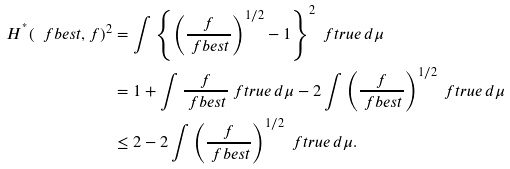<formula> <loc_0><loc_0><loc_500><loc_500>H ^ { ^ { * } } ( \ f b e s t , f ) ^ { 2 } & = \int \left \{ \left ( \frac { f } { \ f b e s t } \right ) ^ { 1 / 2 } - 1 \right \} ^ { 2 } \ f t r u e \, d \mu \\ & = 1 + \int \frac { f } { \ f b e s t } \ f t r u e \, d \mu - 2 \int \left ( \frac { f } { \ f b e s t } \right ) ^ { 1 / 2 } \ f t r u e \, d \mu \\ & \leq 2 - 2 \int \left ( \frac { f } { \ f b e s t } \right ) ^ { 1 / 2 } \ f t r u e \, d \mu .</formula> 